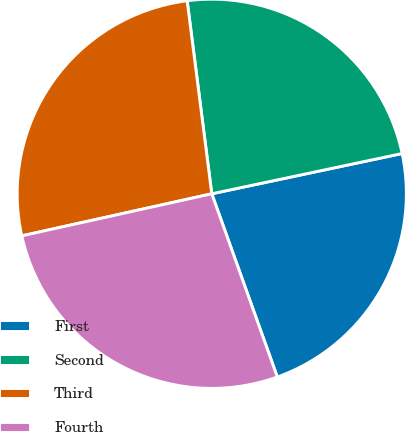Convert chart. <chart><loc_0><loc_0><loc_500><loc_500><pie_chart><fcel>First<fcel>Second<fcel>Third<fcel>Fourth<nl><fcel>22.85%<fcel>23.7%<fcel>26.45%<fcel>27.0%<nl></chart> 